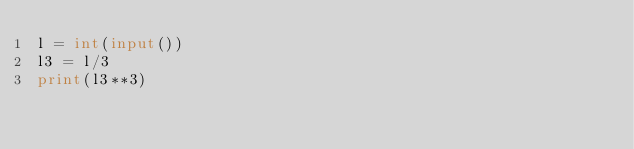<code> <loc_0><loc_0><loc_500><loc_500><_Python_>l = int(input())
l3 = l/3
print(l3**3)</code> 